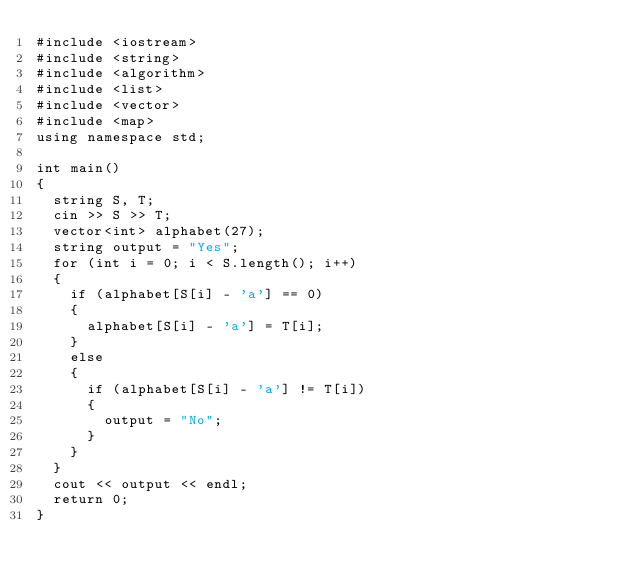<code> <loc_0><loc_0><loc_500><loc_500><_C++_>#include <iostream>
#include <string>
#include <algorithm>
#include <list>
#include <vector>
#include <map>
using namespace std;

int main()
{
	string S, T;
	cin >> S >> T;
	vector<int> alphabet(27);
	string output = "Yes";
	for (int i = 0; i < S.length(); i++)
	{
		if (alphabet[S[i] - 'a'] == 0)
		{
			alphabet[S[i] - 'a'] = T[i];
		}
		else
		{
			if (alphabet[S[i] - 'a'] != T[i])
			{
				output = "No";
			}
		}
	}
	cout << output << endl;
	return 0;
}
</code> 